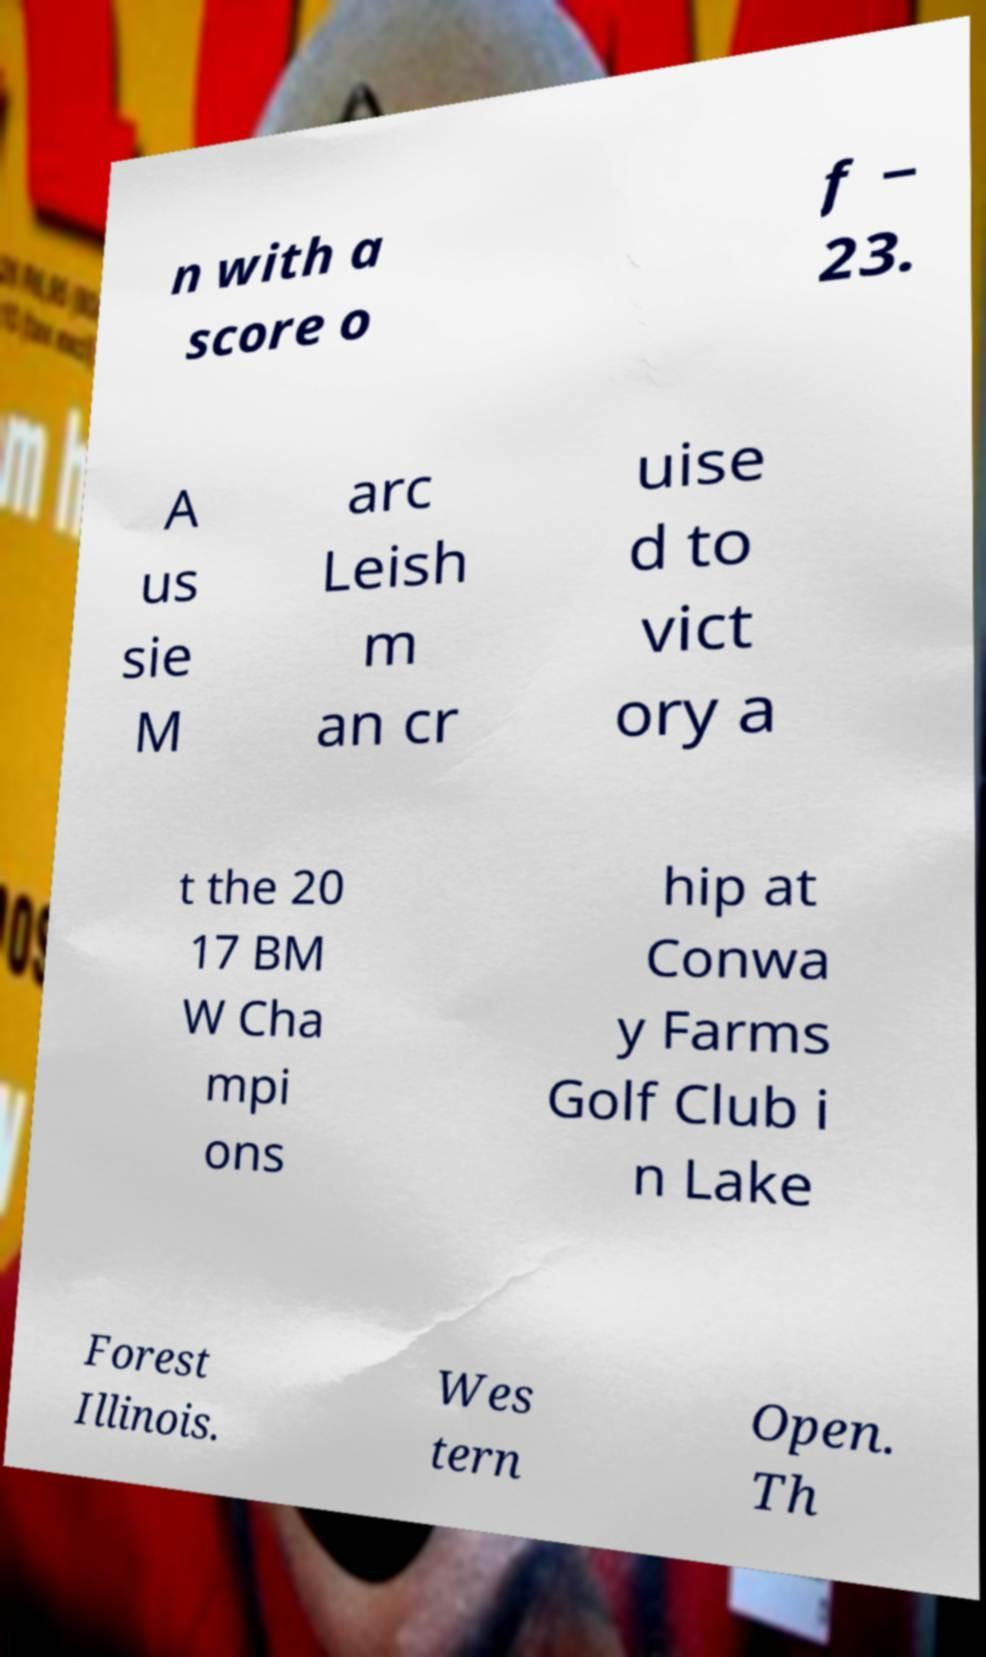Could you assist in decoding the text presented in this image and type it out clearly? n with a score o f − 23. A us sie M arc Leish m an cr uise d to vict ory a t the 20 17 BM W Cha mpi ons hip at Conwa y Farms Golf Club i n Lake Forest Illinois. Wes tern Open. Th 